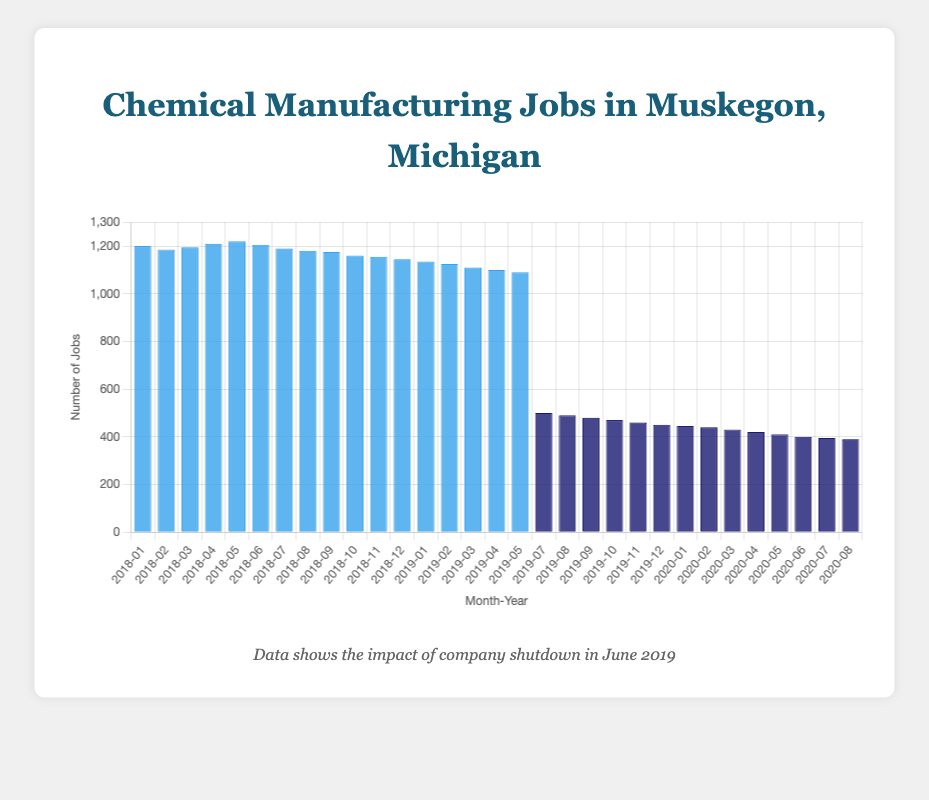What is the average of the number of jobs for January 2018, June 2018, and January 2019? Sum the average jobs in January 2018 (1200), June 2018 (1205), and January 2019 (1135), which gives 1200 + 1205 + 1135 = 3540. Divide by 3 to get the average: 3540 / 3 = 1180.
Answer: 1180 How does the average number of jobs in January 2018 compare with January 2019? The average number of jobs in January 2018 is 1200, and in January 2019, it is 1135. The difference is 1200 - 1135 = 65 jobs, meaning January 2018 had more jobs.
Answer: January 2018 had 65 more jobs What is the trend in the average number of jobs in the months leading up to the company shutdown in June 2019? Starting from January 2019 with 1135 jobs, the number of jobs decreases each month leading up to the company shutdown in June 2019, which had 1090 jobs.
Answer: Decreasing trend What is the difference in the average number of jobs before (May 2019) and after (July 2019) the company shutdown? The average jobs in May 2019 is 1090, and in July 2019, it is 500. The difference is 1090 - 500 = 590 jobs.
Answer: 590 jobs Which period has the higher average monthly jobs, before or after the company shutdown? Calculate the average for both periods. Before: (1200 + 1185 + 1195 + 1210 + 1220 + 1205 + 1190 + 1180 + 1175 + 1160 + 1155 + 1145 + 1135 + 1125 + 1110 + 1100 + 1090) / 17 ≈ 1168.5 After: (500 + 490 + 480 + 470 + 460 + 450 + 445 + 440 + 430 + 420 + 410 + 400 + 395 + 390) / 14 ≈ 439.6. Clearly, the period before the shutdown has a higher average monthly jobs.
Answer: Before the shutdown What is the lowest number of jobs in the dataset, and when did it occur? The lowest number of jobs in the dataset is 390, which occurred in August 2020.
Answer: 390 jobs in August 2020 What visual element indicates the timing of the company shutdown? A vertical red line placed on the chart at June 2019 with a label "Company Shutdown" indicates the timing of the company shutdown.
Answer: Vertical red line How do the colors of the bars change before and after the company shutdown? The bars are blue before the company shutdown and dark blue after the company shutdown.
Answer: From blue to dark blue In June 2018, was the number of jobs above or below 1200? The number of jobs in June 2018 was 1205, which is above 1200.
Answer: Above 1200 Which month in 2020 had the lowest average number of jobs? The lowest average number of jobs in 2020 occurred in August, with 390 jobs.
Answer: August 2020 